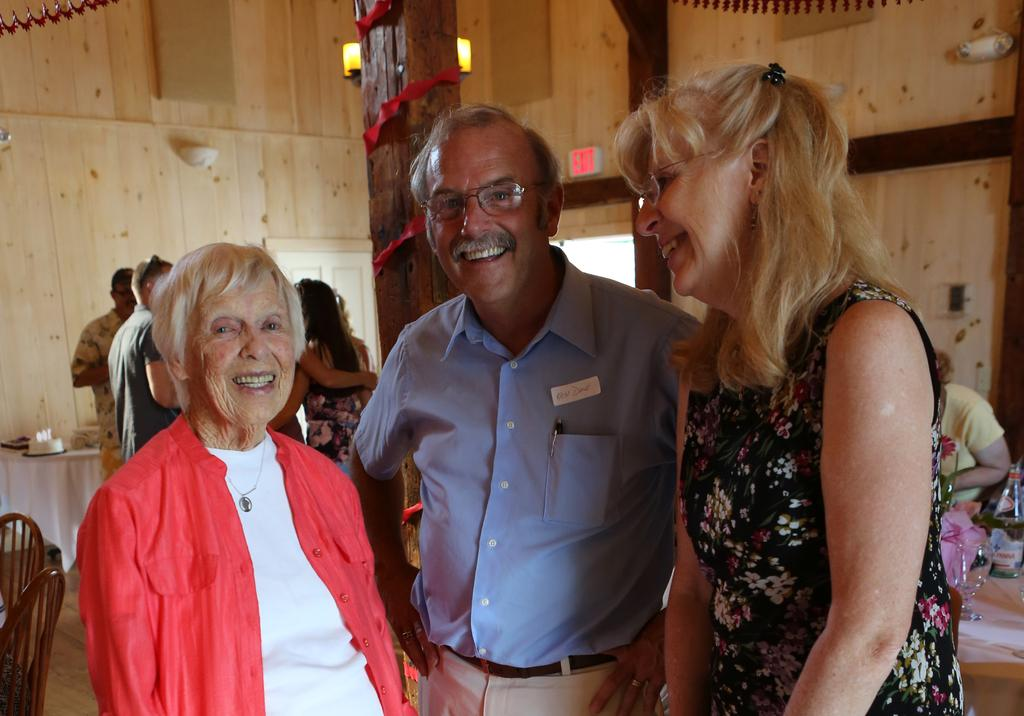What is happening in the center of the image? There are persons standing on the floor in the center of the image. Can you describe the background of the image? There are persons, a table, chairs, a cake, poles, and a wall visible in the background of the image. How many tables can be seen in the image? There is only one table visible in the background of the image. What might be the purpose of the poles in the background? The poles in the background might be used for support or decoration. What year is depicted in the image? The image does not depict a specific year; it is a photograph of a scene. Can you tell me how many zebras are present in the image? There are no zebras present in the image. --- Facts: 1. There is a person sitting on a chair in the image. 2. The person is holding a book. 3. There is a table next to the chair. 4. There is a lamp on the table. 5. The background of the image is dark. Absurd Topics: elephant, ocean, bicycle Conversation: What is the person in the image doing? The person is sitting on a chair in the image. What is the person holding in the image? The person is holding a book. What is located next to the chair in the image? There is a table next to the chair in the image. What is on the table in the image? There is a lamp on the table in the image. Reasoning: Let's think step by step in order to produce the conversation. We start by identifying the main subject in the image, which is the person sitting on a chair. Then, we expand the conversation to include other items that are also visible, such as the book, table, and lamp. Each question is designed to elicit a specific detail about the image that is known from the provided facts. Absurd Question/Answer: Can you tell me how many elephants are visible in the image? There are no elephants present in the image. What type of ocean can be seen in the background of the image? There is no ocean visible in the image; the background is dark. 